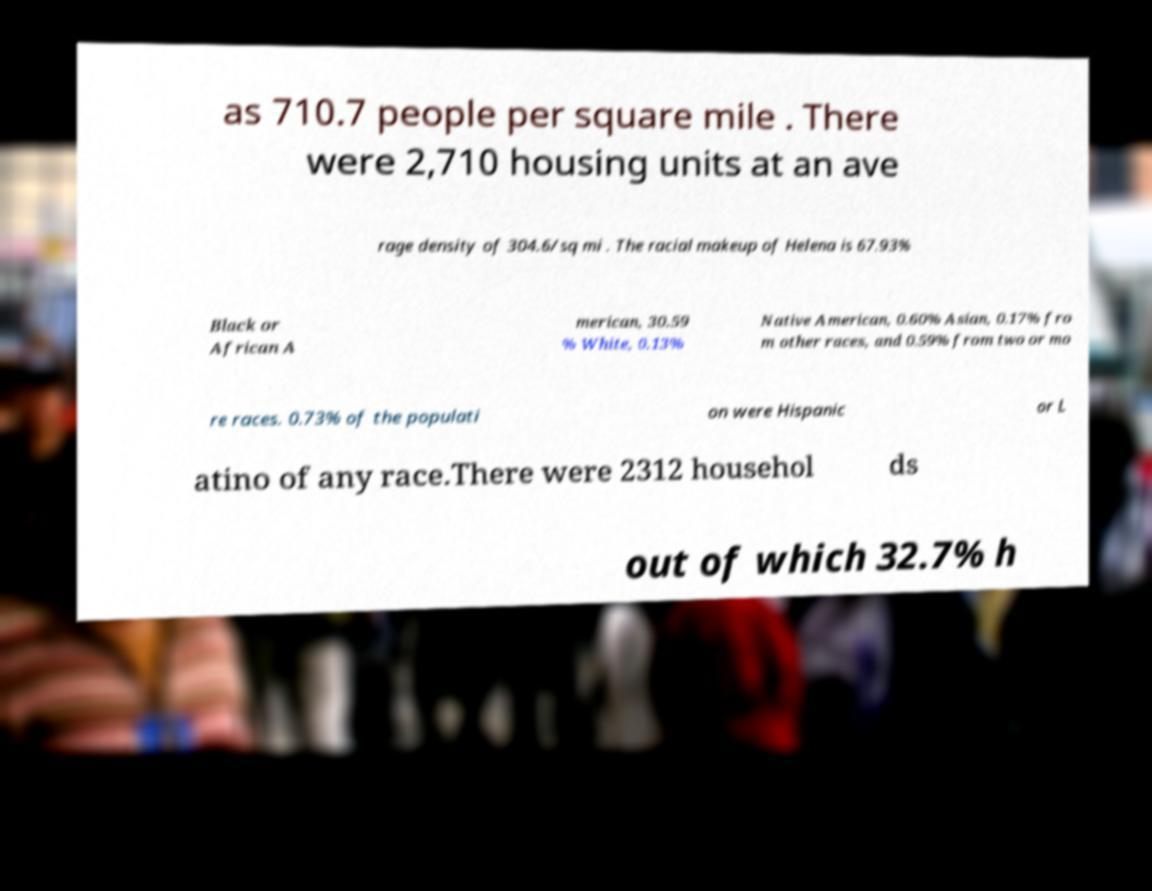Can you accurately transcribe the text from the provided image for me? as 710.7 people per square mile . There were 2,710 housing units at an ave rage density of 304.6/sq mi . The racial makeup of Helena is 67.93% Black or African A merican, 30.59 % White, 0.13% Native American, 0.60% Asian, 0.17% fro m other races, and 0.59% from two or mo re races. 0.73% of the populati on were Hispanic or L atino of any race.There were 2312 househol ds out of which 32.7% h 